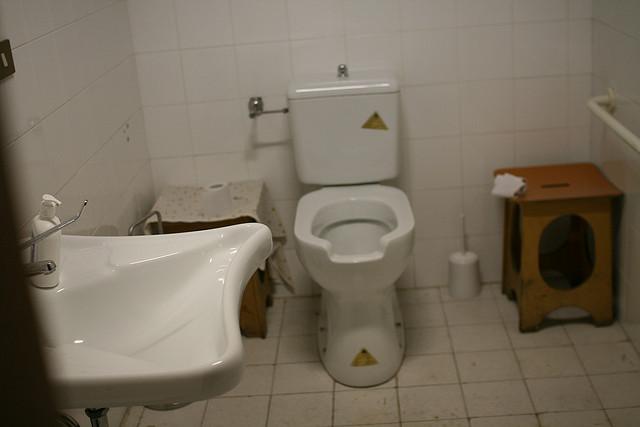Is this toilet functional?
Quick response, please. Yes. What is the toilet seat made of?
Be succinct. Porcelain. How many sinks?
Quick response, please. 1. What is printed on the bottom of the toilets?
Write a very short answer. Triangle. What is the purpose of the thing attached to the toilet?
Be succinct. To flush. Is this restroom out of toilet paper?
Write a very short answer. No. Is the urinal dirty?
Short answer required. No. Is the tap running?
Keep it brief. No. What is the wall made of?
Short answer required. Tile. Is it a good time to run the water?
Keep it brief. Yes. What color is it?
Quick response, please. White. What color is the hand soap?
Keep it brief. White. Is the toilet usable?
Concise answer only. Yes. Is the sink clean?
Be succinct. Yes. What is the silver bar for?
Concise answer only. Flushing. Is there a phone near the toilet?
Be succinct. No. What color is the tile?
Quick response, please. White. Is the sink missing in the photo?
Keep it brief. No. Is the design of this toilet common?
Short answer required. No. How many sinks are being used?
Keep it brief. 0. How many toilets are there?
Be succinct. 1. Is there a mirror in this room?
Keep it brief. No. What is the color of the basket kept in the corner?
Answer briefly. Brown. How many sinks are in this room?
Be succinct. 1. Is the urinal on the floor?
Quick response, please. No. What color are the tiles?
Give a very brief answer. White. What is leaning against the wall?
Answer briefly. Stool. Are the tiles all square?
Give a very brief answer. Yes. What color is the tissue box on the counter?
Concise answer only. White. What color are the tiles on the wall?
Short answer required. White. Would it be dangerous to use this toilet?
Be succinct. No. What is the object standing beside the toilet called?
Keep it brief. Toilet brush. What shape is on the toilet tank?
Give a very brief answer. Triangle. What is on the floor and walls?
Concise answer only. Tile. What does the sign say?
Answer briefly. Warning. 